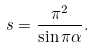<formula> <loc_0><loc_0><loc_500><loc_500>s = \frac { \pi ^ { 2 } } { \sin \pi \alpha } .</formula> 